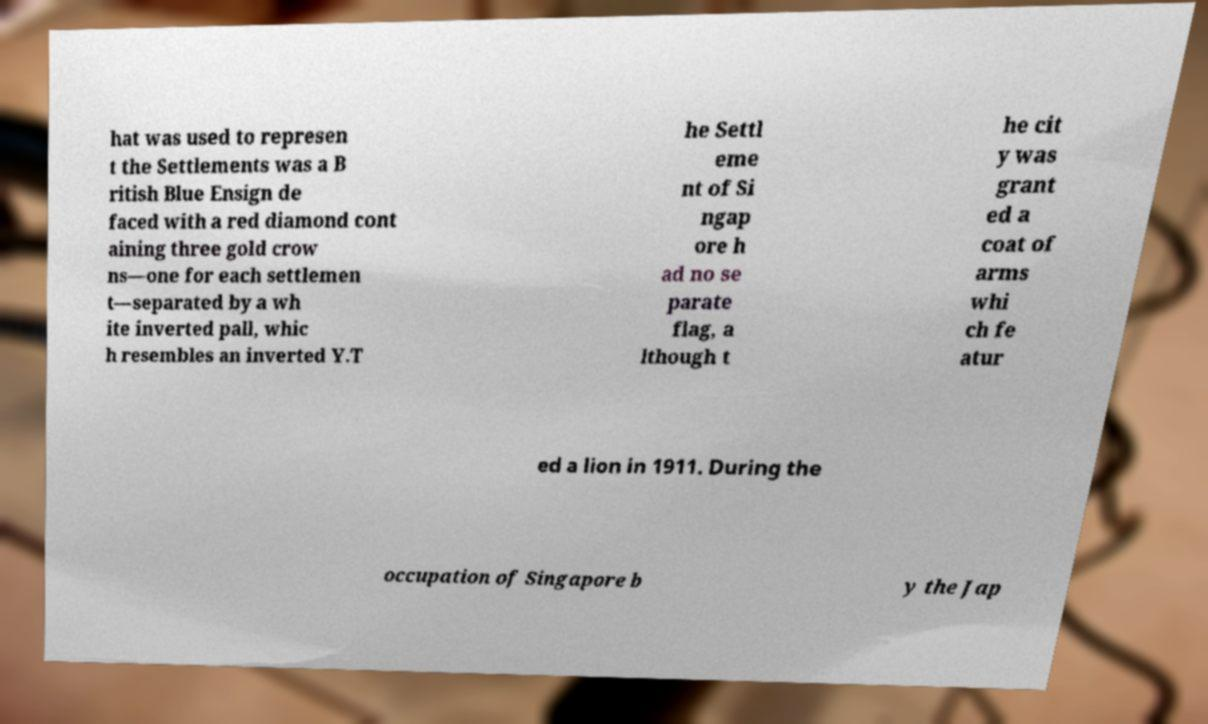Can you accurately transcribe the text from the provided image for me? hat was used to represen t the Settlements was a B ritish Blue Ensign de faced with a red diamond cont aining three gold crow ns—one for each settlemen t—separated by a wh ite inverted pall, whic h resembles an inverted Y.T he Settl eme nt of Si ngap ore h ad no se parate flag, a lthough t he cit y was grant ed a coat of arms whi ch fe atur ed a lion in 1911. During the occupation of Singapore b y the Jap 